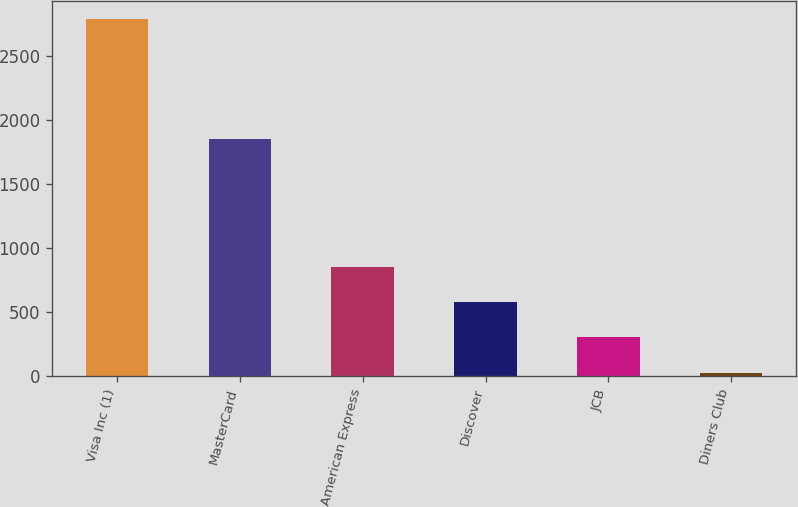<chart> <loc_0><loc_0><loc_500><loc_500><bar_chart><fcel>Visa Inc (1)<fcel>MasterCard<fcel>American Express<fcel>Discover<fcel>JCB<fcel>Diners Club<nl><fcel>2793<fcel>1852<fcel>855.4<fcel>578.6<fcel>301.8<fcel>25<nl></chart> 